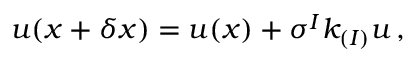<formula> <loc_0><loc_0><loc_500><loc_500>u ( x + \delta x ) = u ( x ) + \sigma ^ { I } k _ { ( I ) } u \, ,</formula> 